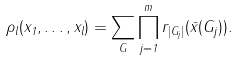Convert formula to latex. <formula><loc_0><loc_0><loc_500><loc_500>\rho _ { l } ( x _ { 1 } , \dots , x _ { l } ) = \sum _ { G } \prod ^ { m } _ { j = 1 } r _ { | G _ { j } | } ( \bar { x } ( G _ { j } ) ) .</formula> 